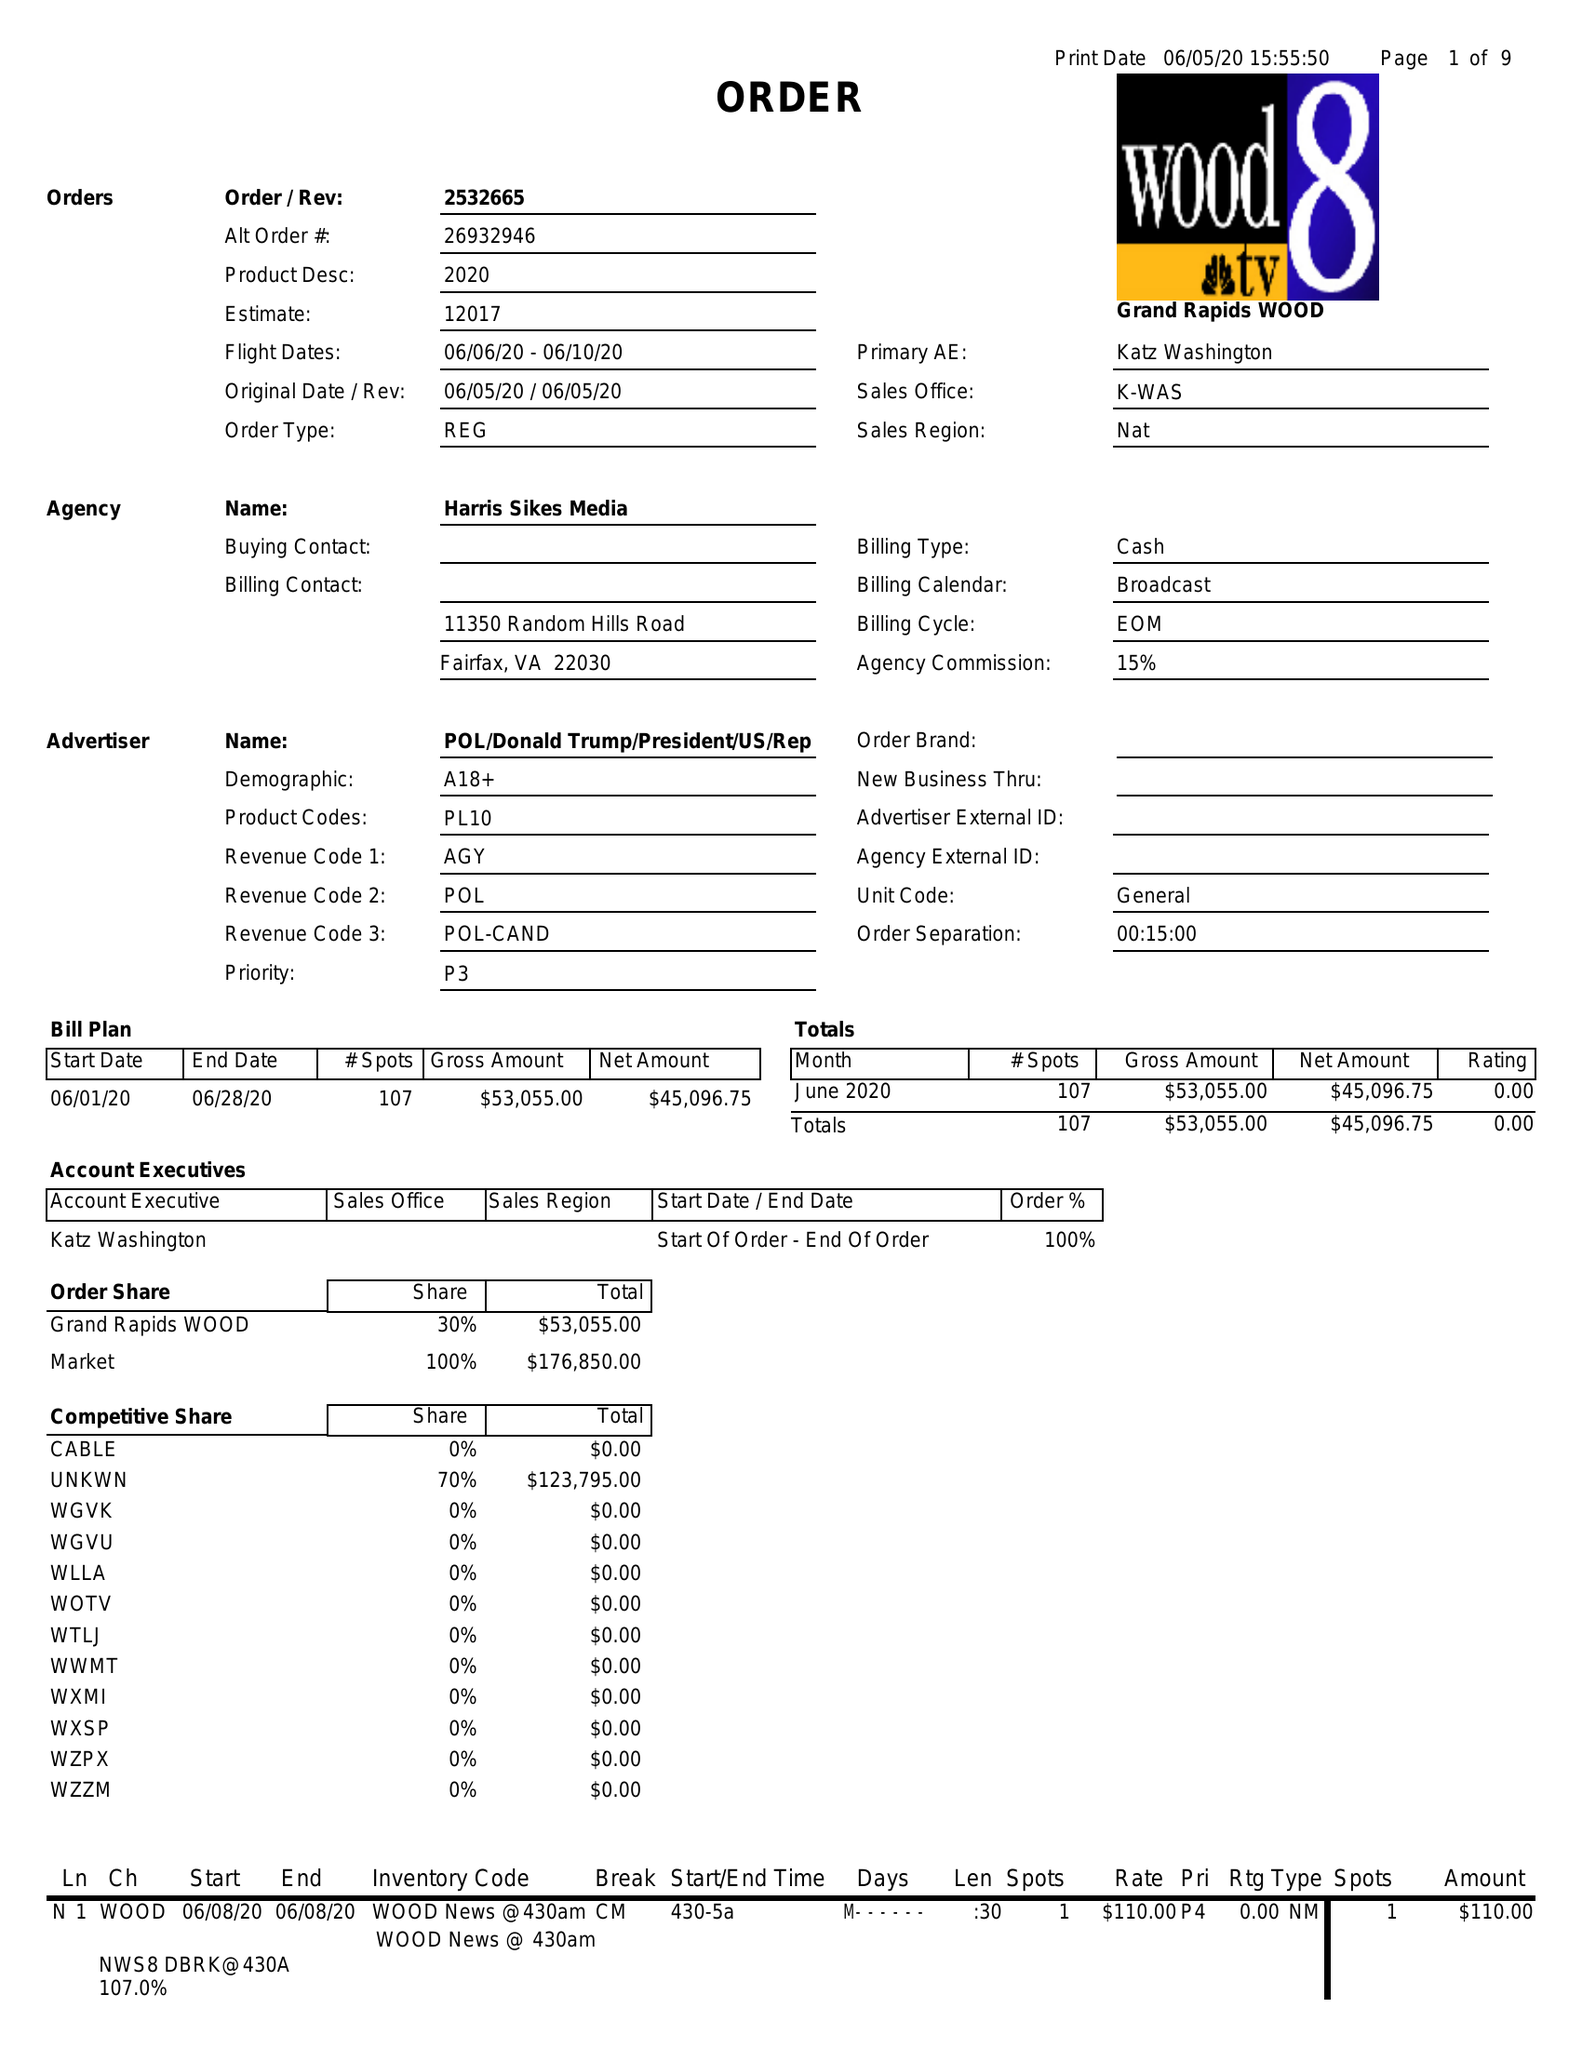What is the value for the flight_from?
Answer the question using a single word or phrase. 06/06/20 